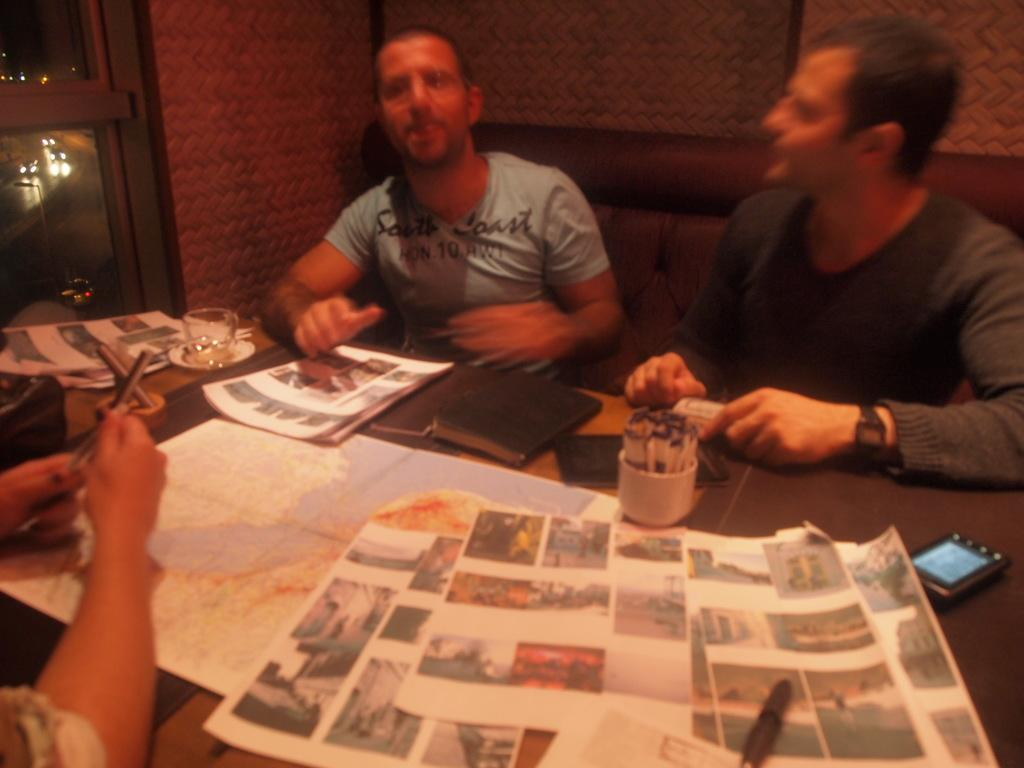How many people are in the image? There are two people in the image. What are the people doing in the image? The people are sitting on chairs. What is in front of the people? There is a table in front of the people. What items can be seen on the table? There are newspapers, a cup, and a saucer on the table. What month is it in the image? The month cannot be determined from the image, as there is no information about the date or time of year. --- 